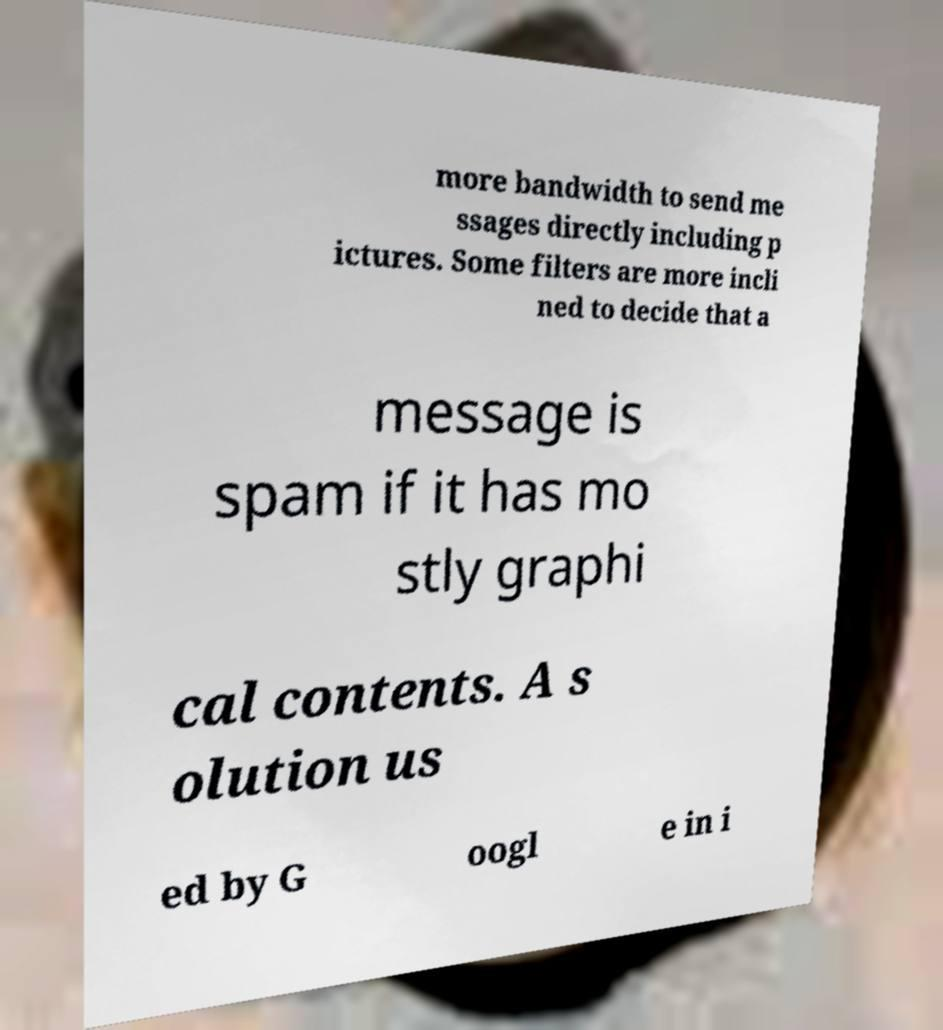For documentation purposes, I need the text within this image transcribed. Could you provide that? more bandwidth to send me ssages directly including p ictures. Some filters are more incli ned to decide that a message is spam if it has mo stly graphi cal contents. A s olution us ed by G oogl e in i 